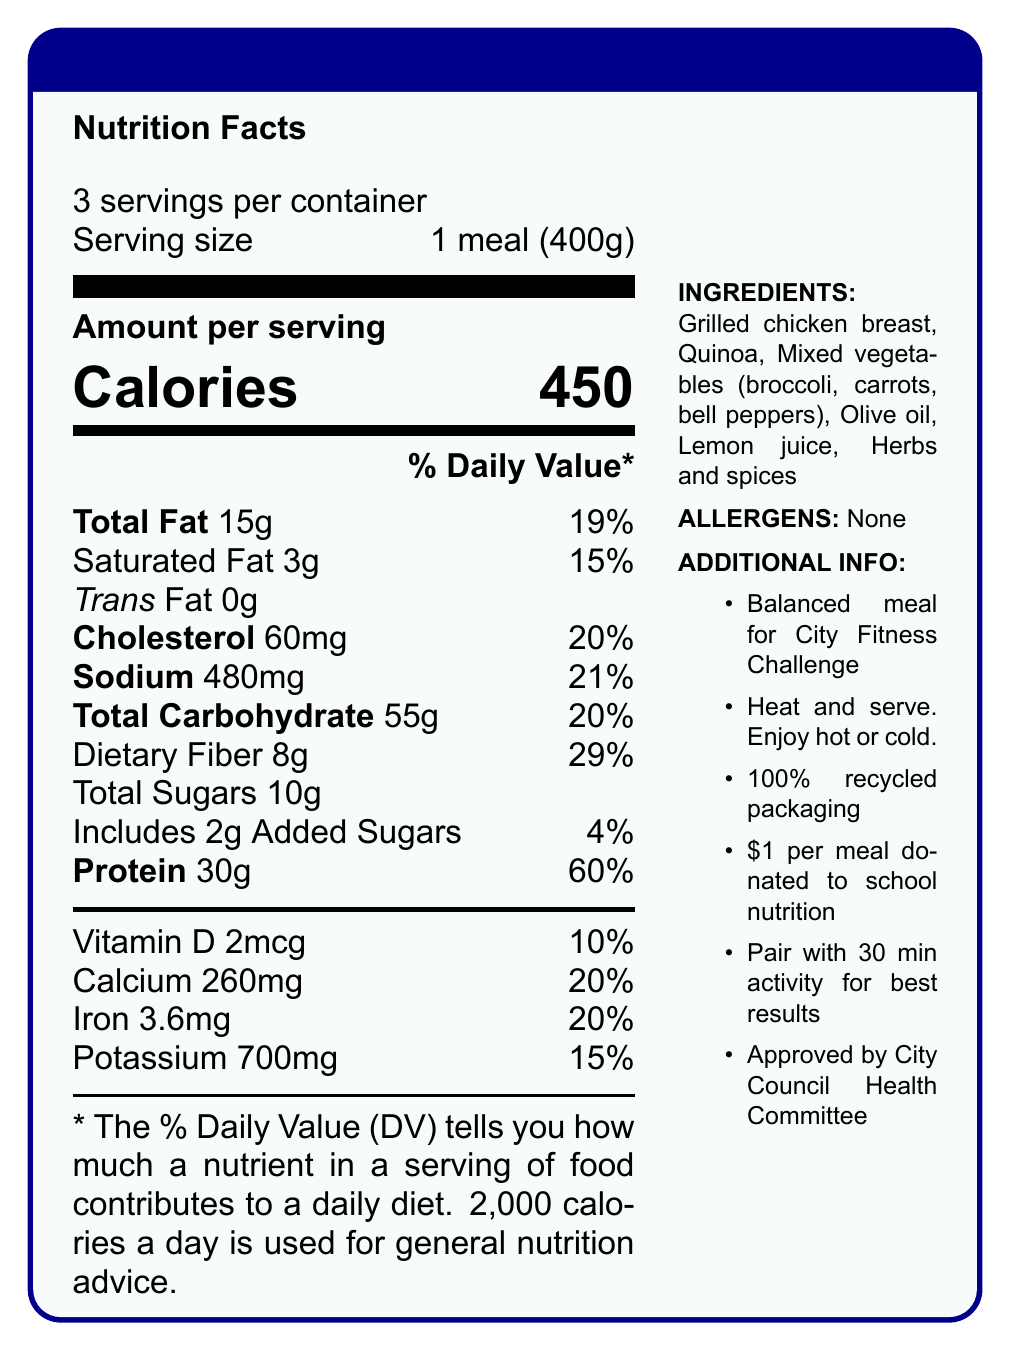what is the serving size for the Community Fitness Challenge Meal Plan? The serving size is explicitly stated in the document as "1 meal (400g)".
Answer: 1 meal (400g) how many calories are there per serving? The document lists "Calories" as 450 per serving under the "Amount per serving" section.
Answer: 450 What percentage of the daily value for protein does one serving of the meal provide? The percentage of the daily value for protein is 60%, as stated under the nutrient breakdown.
Answer: 60% What are the ingredients listed in the meal plan? The ingredients are detailed in the "INGREDIENTS" section of the sidebar.
Answer: Grilled chicken breast, Quinoa, Mixed vegetables (broccoli, carrots, bell peppers), Olive oil, Lemon juice, Herbs and spices How much sodium is there per serving and what is its daily value percentage? The document shows sodium content as 480mg per serving and lists its daily value percentage as 21%.
Answer: 480mg, 21% What additional information is provided about the sustainability of the meal packaging? The sidebar's "ADDITIONAL INFO" section mentions that the packaging is made from 100% recycled materials.
Answer: 100% recycled packaging How much dietary fiber does one meal provide? A. 4g B. 6g C. 8g D. 10g According to the document, one meal contains 8g of dietary fiber, with its daily value percentage at 29%.
Answer: C Which vitamin and its amount is mentioned in the nutrition facts? A. Vitamin A, 5mcg B. Vitamin C, 10mg C. Vitamin D, 2mcg D. Vitamin K, 1mg The nutrition facts list Vitamin D at 2mcg.
Answer: C Is there any trans fat in the meal? The document indicates "Trans Fat 0g", meaning there is no trans fat in the meal.
Answer: No Has the meal plan been approved by a governing body? The additional info section at the end mentions that the meal plan has been reviewed and approved by the City Council Health Committee.
Answer: Yes Summarize the main purpose of this meal plan document. The document describes the nutritional content, including calorie count and percentages of daily values for various nutrients, ingredients, allergens, and additional notes highlighting preparation instructions, sustainability efforts, and community impact.
Answer: The Community Fitness Challenge Meal Plan document provides detailed nutritional information, ingredients, and additional information about a balanced meal designed to promote health and community engagement as part of a city-wide fitness challenge. What is the main depot for sales of these meal plans? The document does not specify where the meal plans are sold or any depot information.
Answer: Cannot be determined How many servings are provided per container? The document clearly states "3 servings per container" at the top right corner under the title "Nutrition Facts".
Answer: 3 